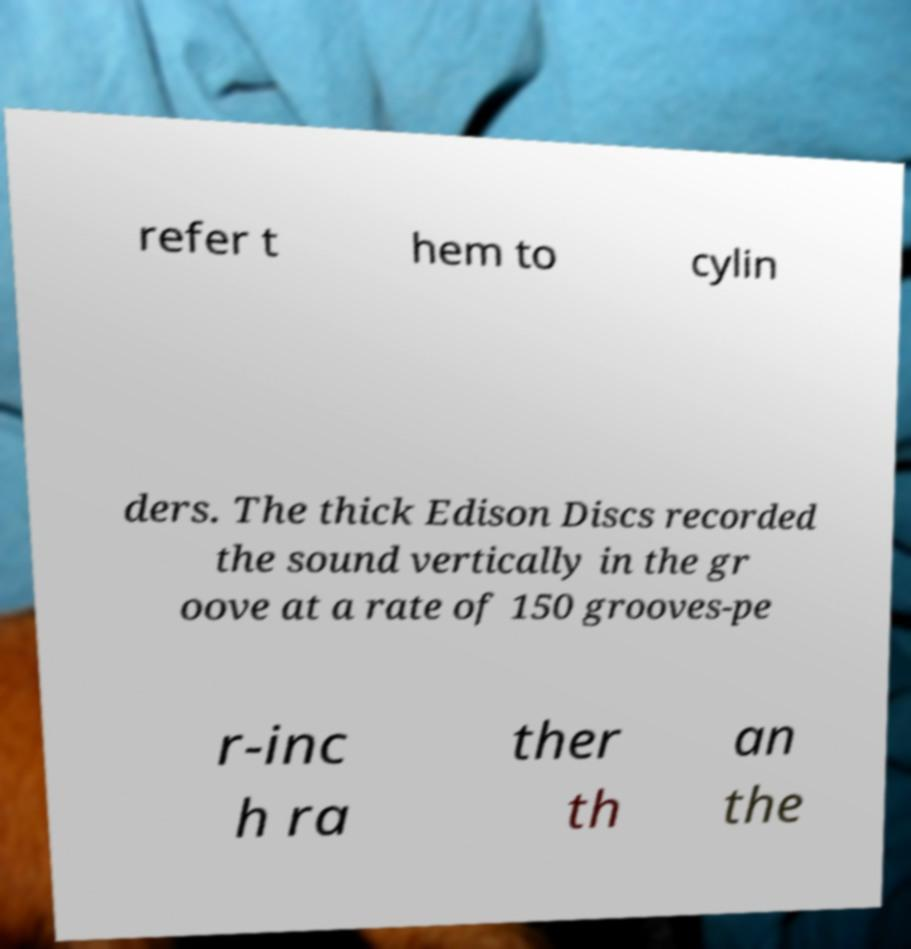Can you accurately transcribe the text from the provided image for me? refer t hem to cylin ders. The thick Edison Discs recorded the sound vertically in the gr oove at a rate of 150 grooves-pe r-inc h ra ther th an the 